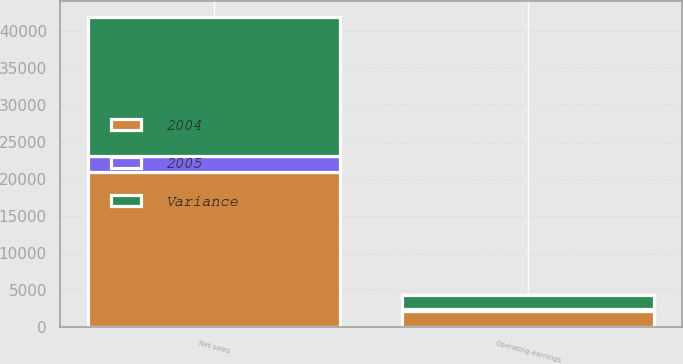<chart> <loc_0><loc_0><loc_500><loc_500><stacked_bar_chart><ecel><fcel>Net sales<fcel>Operating earnings<nl><fcel>2004<fcel>20975<fcel>2179<nl><fcel>Variance<fcel>18868<fcel>1931<nl><fcel>2005<fcel>2107<fcel>248<nl></chart> 